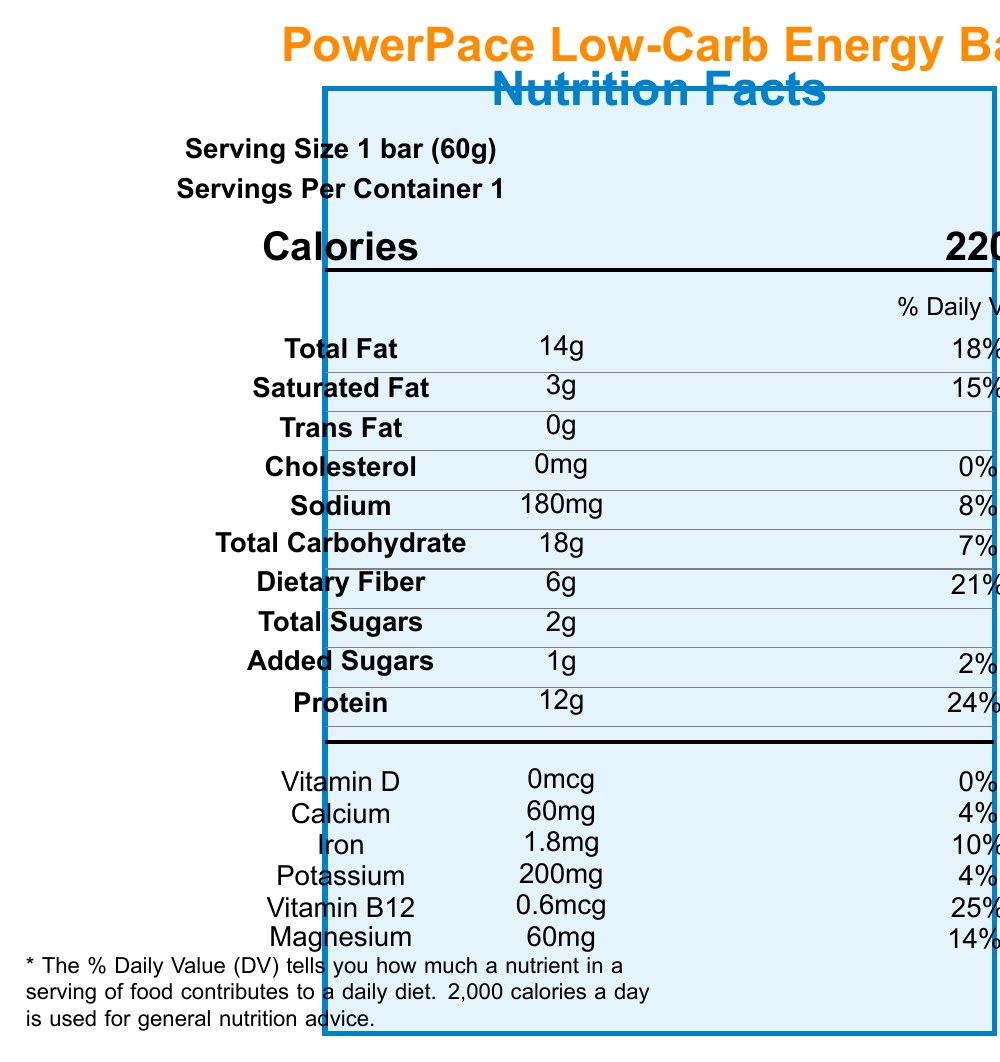how many servings are in the container? The document states "Servings Per Container 1".
Answer: 1 what is the serving size of the energy bar? The document specifies "Serving Size 1 bar (60g)".
Answer: 1 bar (60g) how many calories does one serving contain? The document lists "Calories 220" for one serving size.
Answer: 220 how much total fat is in one serving? Under "Total Fat," it is noted that there are "14g" of total fat per serving.
Answer: 14g what is the percentage daily value for dietary fiber in this product? The document shows "Dietary Fiber 6g 21%" in the nutrient information.
Answer: 21% how much sodium is there in one bar? It states "Sodium 180mg" in the nutrient section.
Answer: 180mg what is the daily value percentage of calcium? A. 2% B. 4% C. 10% D. 14% The document mentions "Calcium 60mg 4%" in the vitamins and minerals section.
Answer: B. 4% what is the total carbohydrate content in one serving? A. 21g B. 20g C. 18g D. 2g According to the document, "Total Carbohydrate 18g".
Answer: C. 18g does the product contain any vitamin D? The document states "Vitamin D 0mcg 0%," showing there is no vitamin D present.
Answer: No is the product non-GMO certified? The document lists "Non-GMO Project Verified" under certifications.
Answer: Yes who manufactures the PowerPace Low-Carb Energy Bar? The document mentions it is "manufactured by EnduroFuel Nutrition, Inc.".
Answer: EnduroFuel Nutrition, Inc. list three performance features of this energy bar. These performance notes are stated in the document under the "performanceNotes" section.
Answer: 1. Designed for sustained energy release during endurance activities, 2. Low glycemic impact to maintain stable blood sugar levels, 3. Rich in medium-chain triglycerides (MCTs) for quick energy conversion how much protein does this energy bar contain? The document shows "Protein 12g" in the nutrient information section.
Answer: 12g what are the top three ingredients in the list? These are the first three ingredients listed in the ingredients section.
Answer: 1. Almonds, 2. Whey Protein Isolate, 3. Soluble Corn Fiber does the product contain any allergens? The document mentions "Contains: Milk, Tree Nuts (Almonds)" under allergen information.
Answer: Yes summarize the main idea of the document. This summary is a more detailed description of what the document covers, representing its entire content.
Answer: The document describes the nutritional content of the PowerPace Low-Carb Energy Bar, including its serving size, calories, macronutrients, vitamins, and minerals. It provides information on ingredients, allergen warnings, performance features, storage, and certifications. what is the price of the PowerPace Low-Carb Energy Bar? The document does not include any information about the price of the product.
Answer: Not enough information 